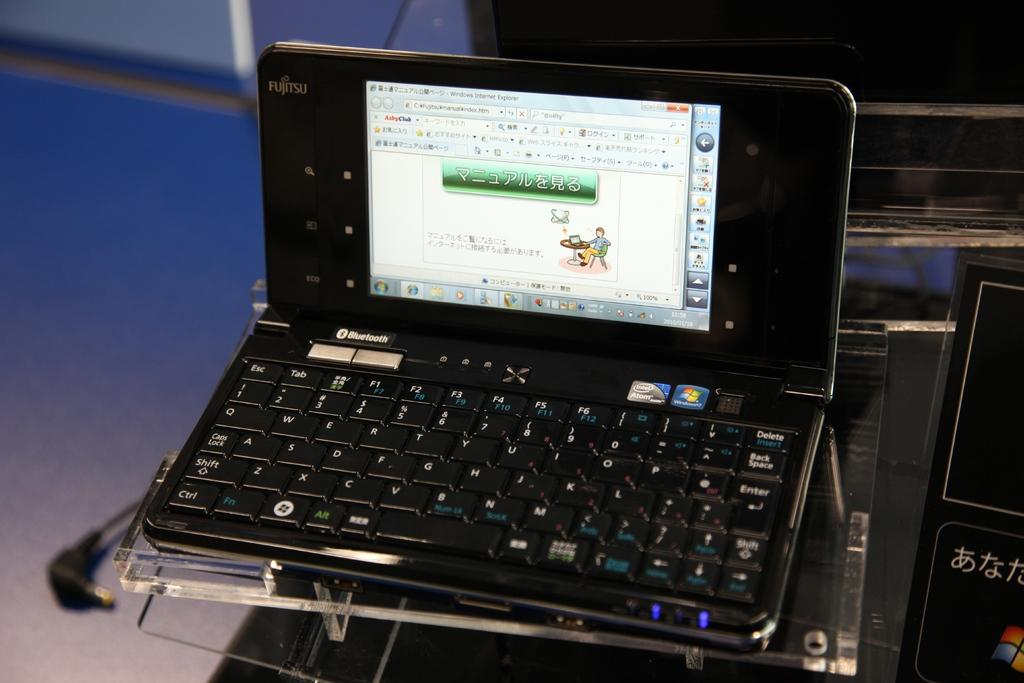<image>
Describe the image concisely. A Fujitsu computer, shows a man sitting a table on the screen display 